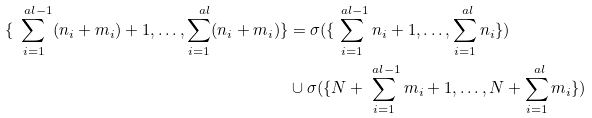Convert formula to latex. <formula><loc_0><loc_0><loc_500><loc_500>\{ \sum _ { i = 1 } ^ { \ a l - 1 } ( n _ { i } + m _ { i } ) + 1 , \dots , \sum _ { i = 1 } ^ { \ a l } ( n _ { i } + m _ { i } ) \} & = \sigma ( \{ \sum _ { i = 1 } ^ { \ a l - 1 } n _ { i } + 1 , \dots , \sum _ { i = 1 } ^ { \ a l } n _ { i } \} ) \\ & \cup \sigma ( \{ N + \sum _ { i = 1 } ^ { \ a l - 1 } m _ { i } + 1 , \dots , N + \sum _ { i = 1 } ^ { \ a l } m _ { i } \} )</formula> 